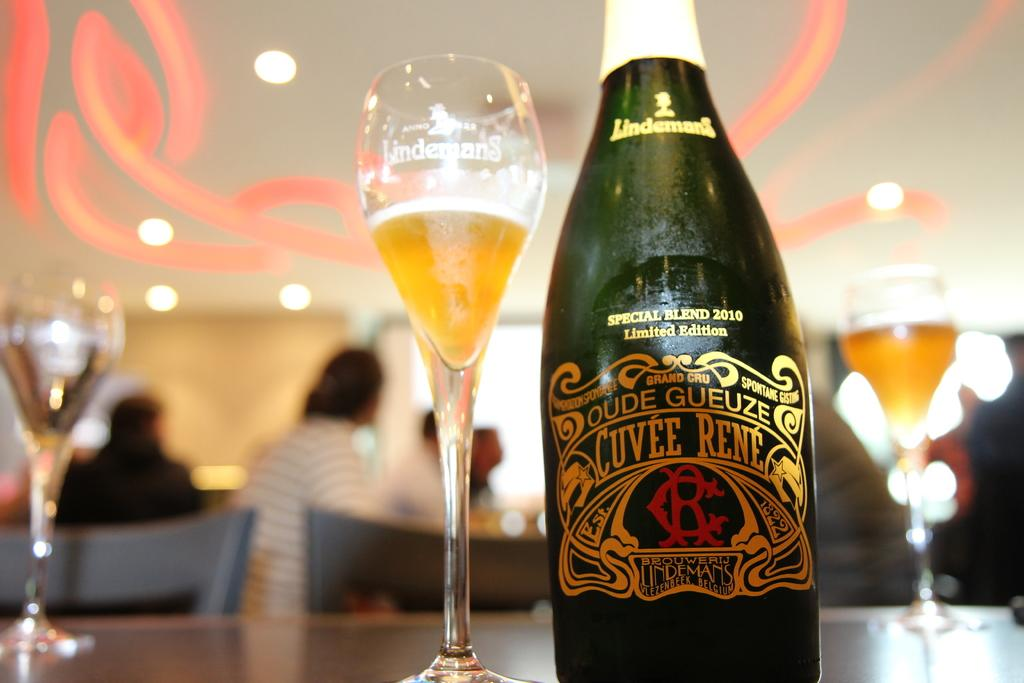<image>
Create a compact narrative representing the image presented. A bottle label says it is a special blend from 2010. 